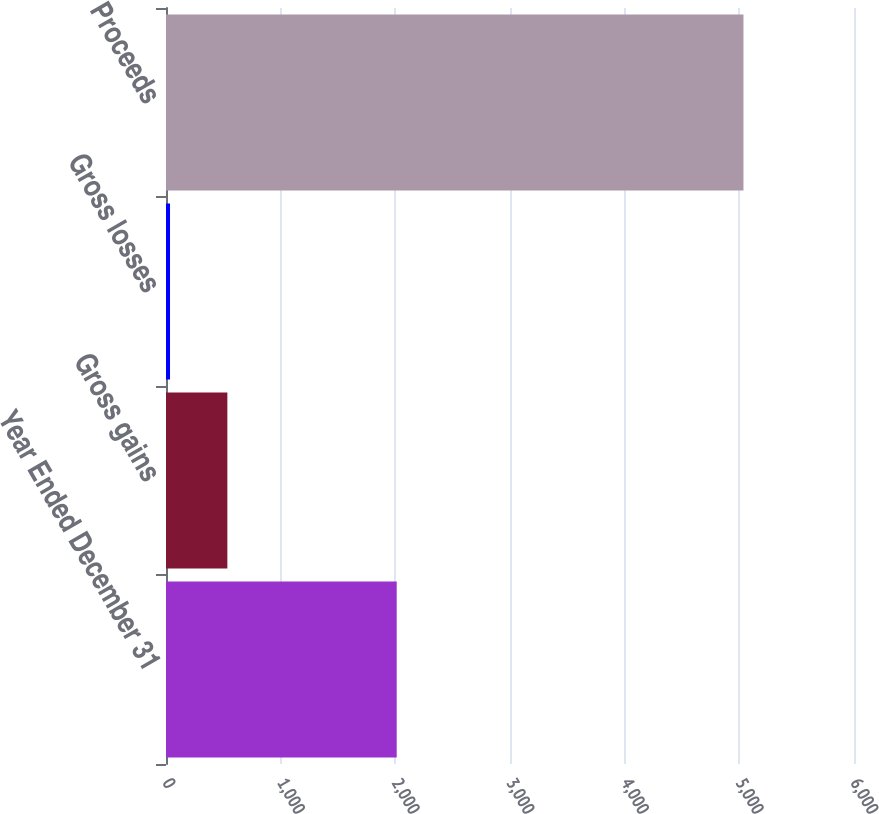Convert chart. <chart><loc_0><loc_0><loc_500><loc_500><bar_chart><fcel>Year Ended December 31<fcel>Gross gains<fcel>Gross losses<fcel>Proceeds<nl><fcel>2012<fcel>535.1<fcel>35<fcel>5036<nl></chart> 